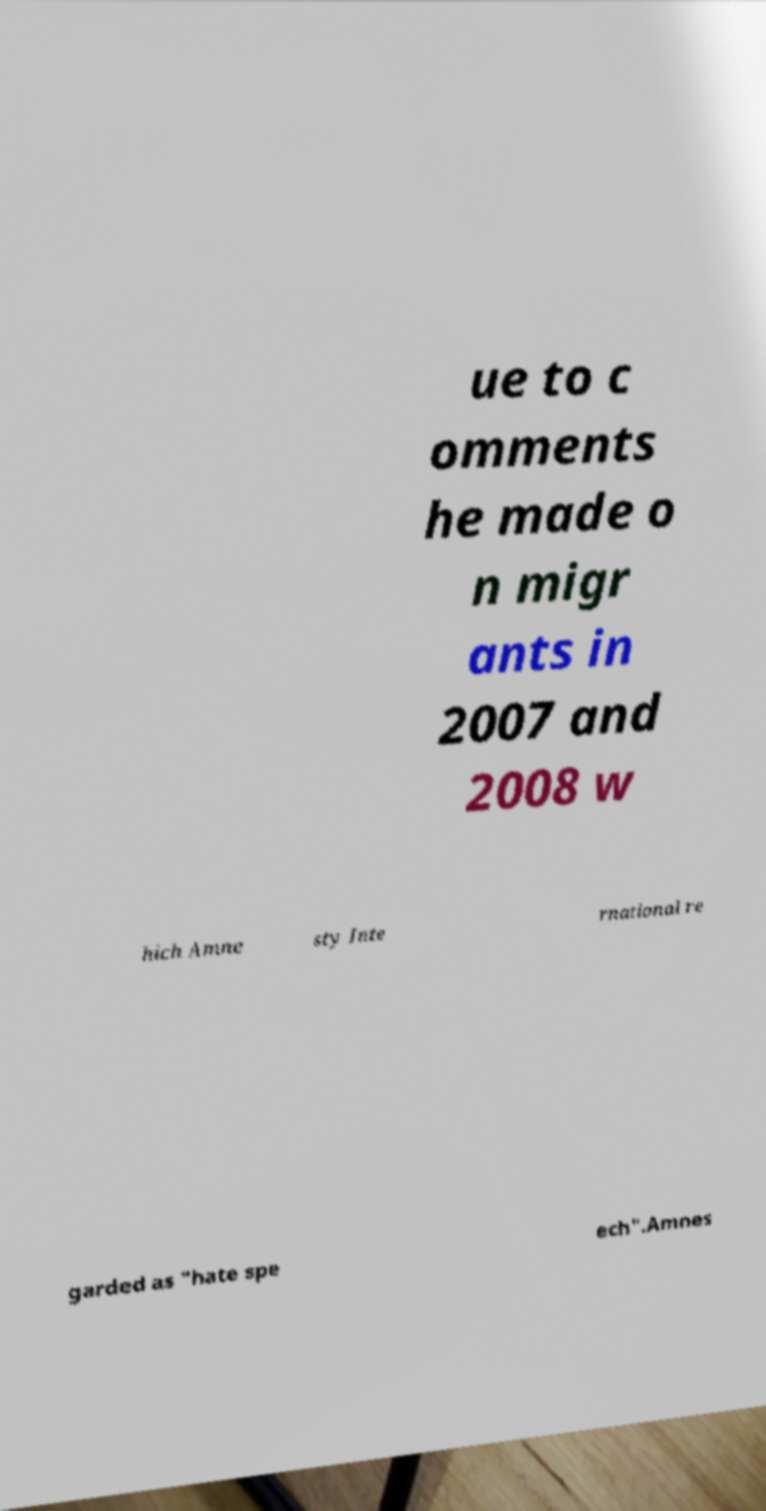Can you read and provide the text displayed in the image?This photo seems to have some interesting text. Can you extract and type it out for me? ue to c omments he made o n migr ants in 2007 and 2008 w hich Amne sty Inte rnational re garded as "hate spe ech".Amnes 